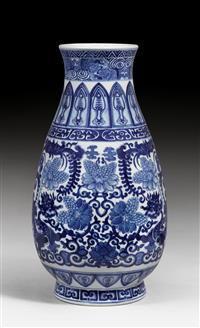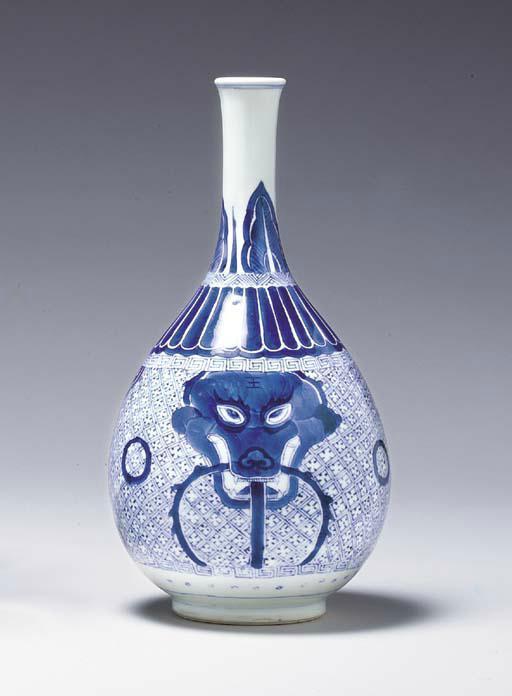The first image is the image on the left, the second image is the image on the right. Analyze the images presented: Is the assertion "One vase has a bulge in the stem." valid? Answer yes or no. No. The first image is the image on the left, the second image is the image on the right. Considering the images on both sides, is "The vases in the left and right images do not have the same shape, and at least one vase features a dragon-like creature on it." valid? Answer yes or no. Yes. 